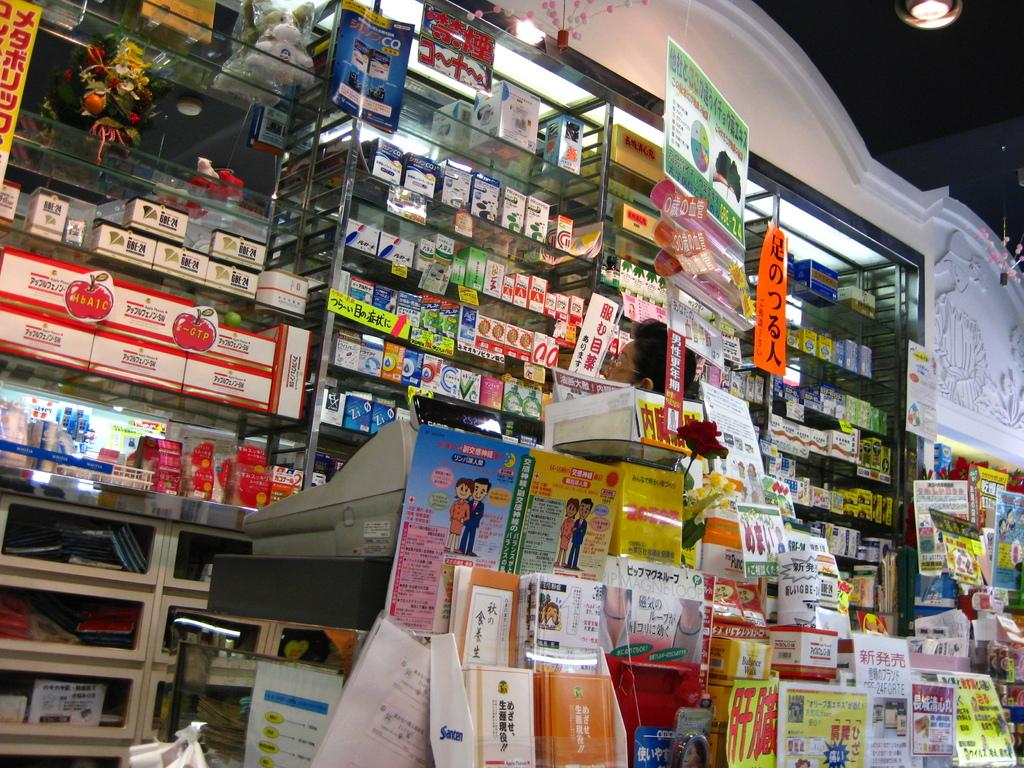What type of establishment is depicted in the image? The image appears to depict a store. What can be seen inside the store? There are many items visible in the store. Can you describe the machine on the table in the center of the image? We start by identifying the main subject of the image, which is a store. Then, we describe the contents of the store, mentioning the presence of many items. Finally, we focus on a specific object in the image, the machine on the table, and note that there is a person behind it. Absurd Question/Answer: How many clovers are on the table next to the machine? There are no clovers visible in the image; the focus is on the machine and the person behind it. What type of tree is growing in the store? There is no tree growing in the store; the focus is on the store, the items, and the machine with a person behind it. 